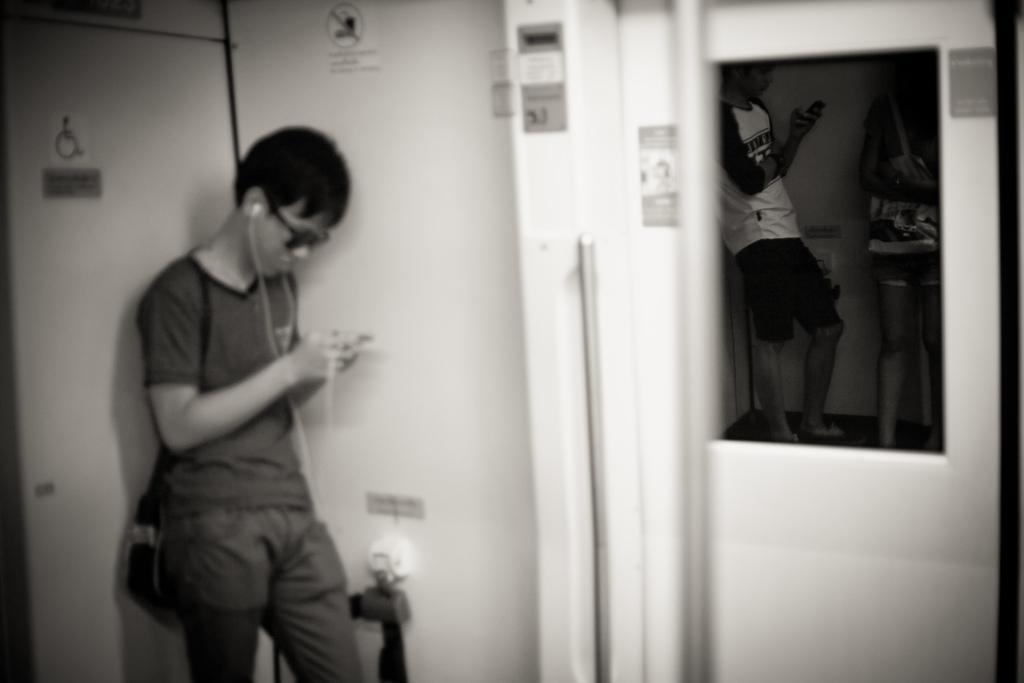How would you summarize this image in a sentence or two? This is a black and white image. In this image we can see a person standing wearing the headset holding a device. We can also see some papers and a device on a wall. On the right side we can see a man and a woman standing beside a door. In that we can see a man standing holding a device. 